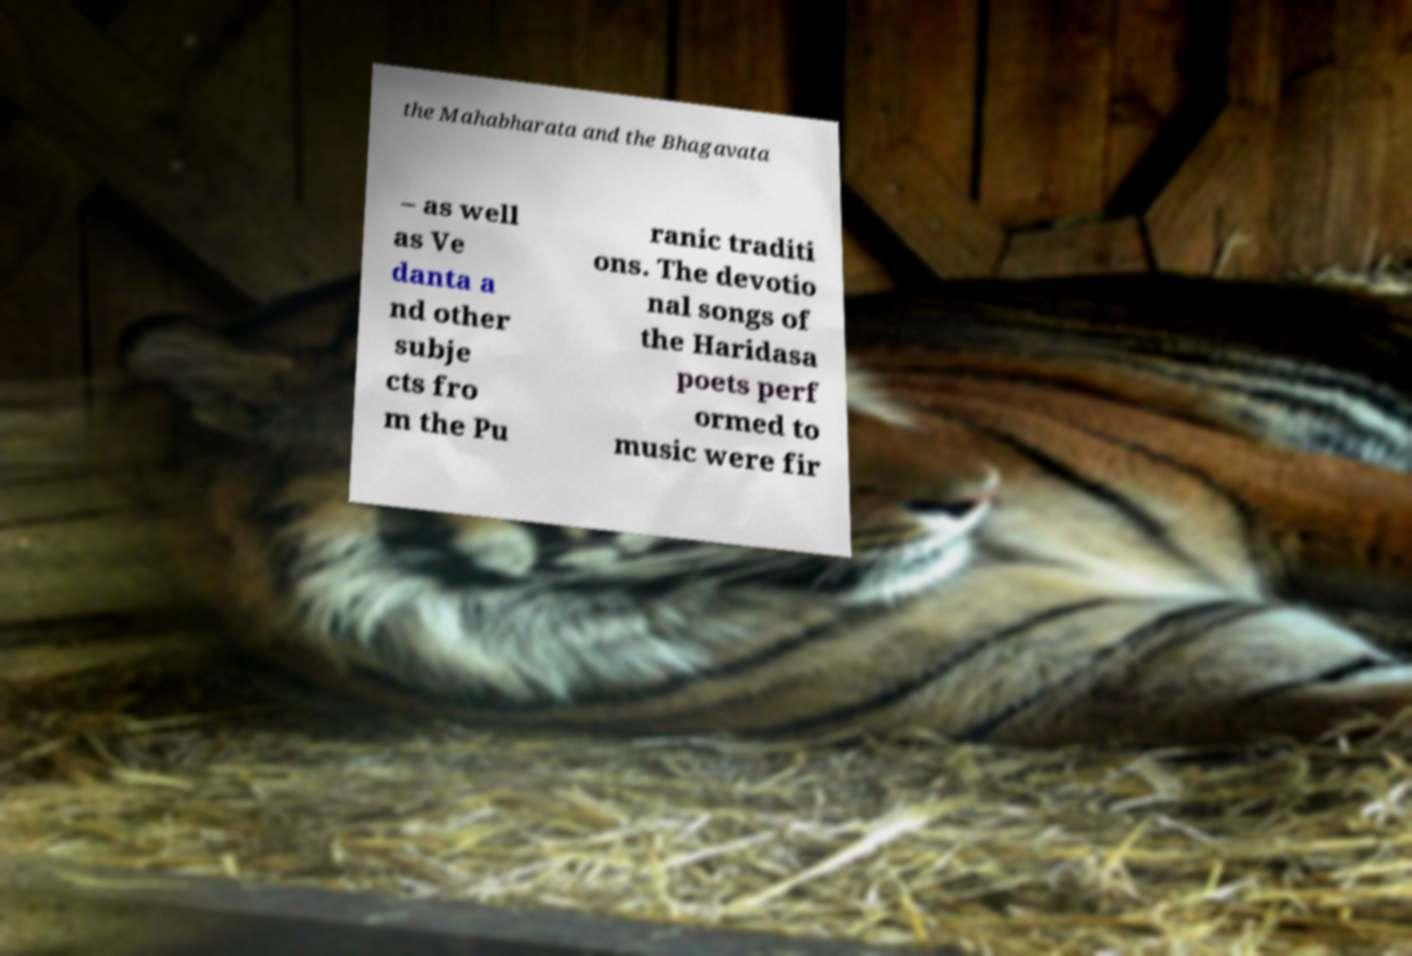Can you read and provide the text displayed in the image?This photo seems to have some interesting text. Can you extract and type it out for me? the Mahabharata and the Bhagavata – as well as Ve danta a nd other subje cts fro m the Pu ranic traditi ons. The devotio nal songs of the Haridasa poets perf ormed to music were fir 